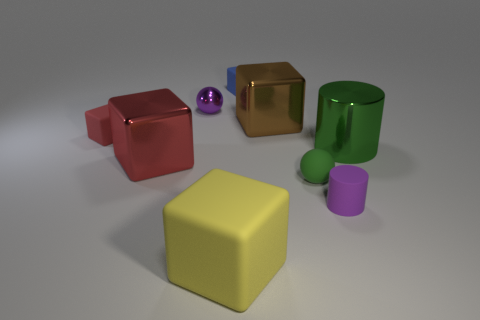Are the objects arranged in a particular pattern? The objects do not adhere to any strict pattern, but they are spaced out across the surface, allowing each item to be distinctly visible without crowding the others. Do the sizes of these objects vary? Yes, the sizes vary. The yellow cube is the largest, followed by the green cylinder, the red cube, the gold cube, and the blue cube, while the purple sphere and the pink cylinder are the smallest objects present. 